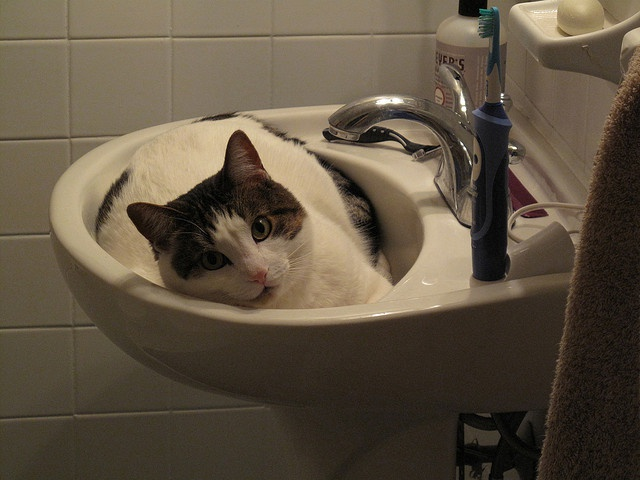Describe the objects in this image and their specific colors. I can see sink in gray, black, and tan tones, cat in gray, black, and tan tones, toothbrush in gray and black tones, and bottle in gray, maroon, and black tones in this image. 